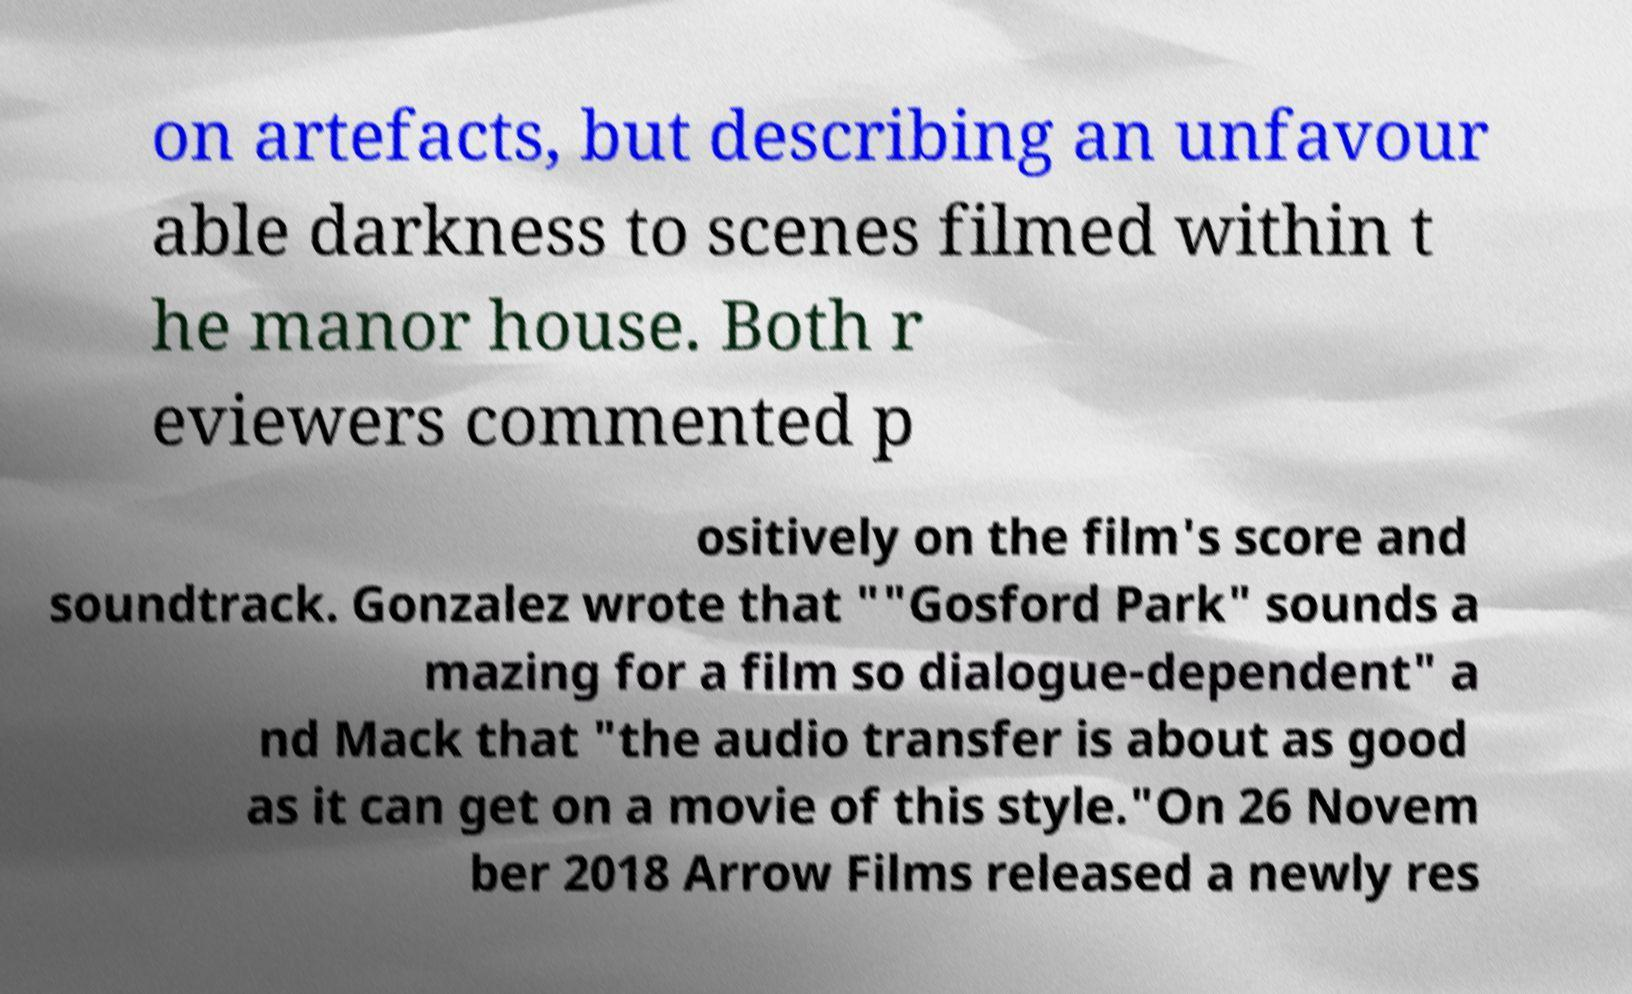There's text embedded in this image that I need extracted. Can you transcribe it verbatim? on artefacts, but describing an unfavour able darkness to scenes filmed within t he manor house. Both r eviewers commented p ositively on the film's score and soundtrack. Gonzalez wrote that ""Gosford Park" sounds a mazing for a film so dialogue-dependent" a nd Mack that "the audio transfer is about as good as it can get on a movie of this style."On 26 Novem ber 2018 Arrow Films released a newly res 